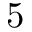Convert formula to latex. <formula><loc_0><loc_0><loc_500><loc_500>5</formula> 